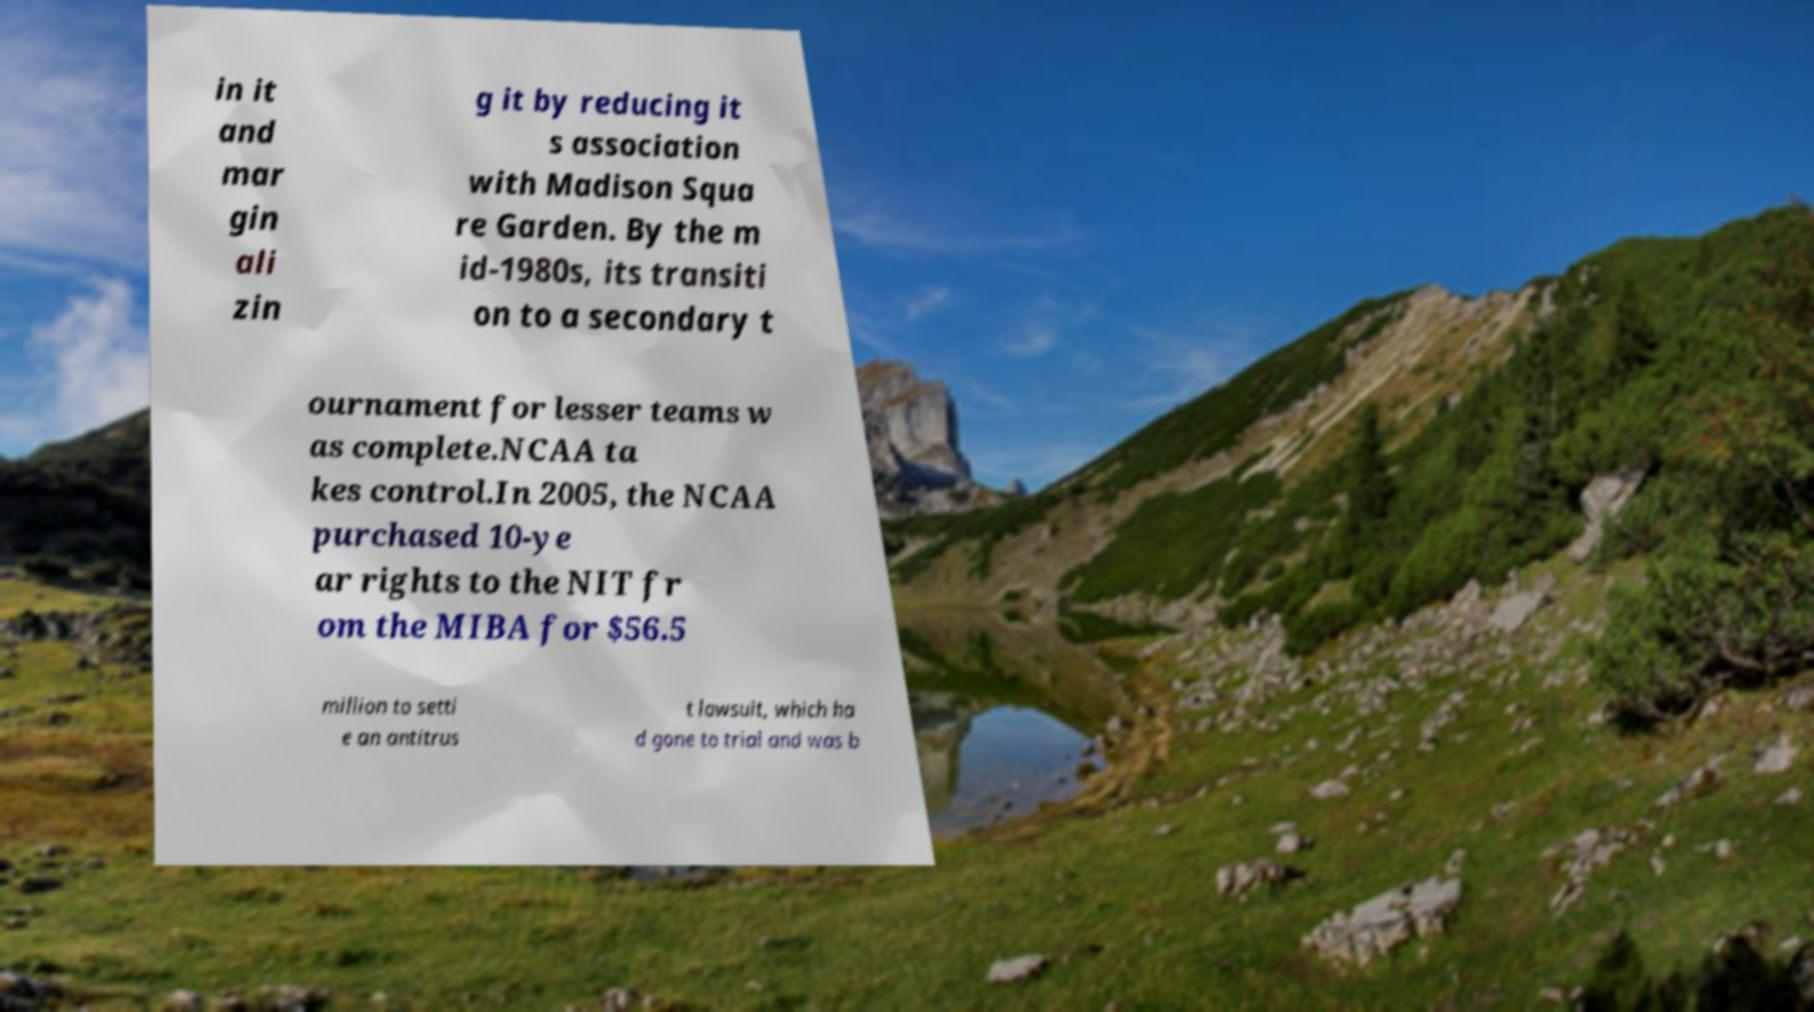What messages or text are displayed in this image? I need them in a readable, typed format. in it and mar gin ali zin g it by reducing it s association with Madison Squa re Garden. By the m id-1980s, its transiti on to a secondary t ournament for lesser teams w as complete.NCAA ta kes control.In 2005, the NCAA purchased 10-ye ar rights to the NIT fr om the MIBA for $56.5 million to settl e an antitrus t lawsuit, which ha d gone to trial and was b 